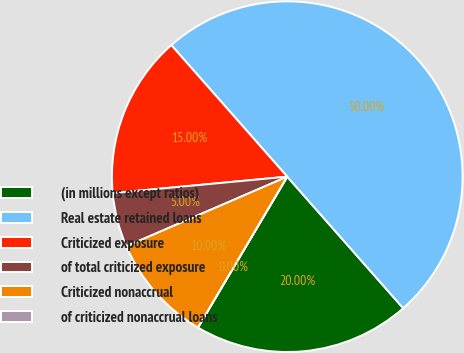Convert chart. <chart><loc_0><loc_0><loc_500><loc_500><pie_chart><fcel>(in millions except ratios)<fcel>Real estate retained loans<fcel>Criticized exposure<fcel>of total criticized exposure<fcel>Criticized nonaccrual<fcel>of criticized nonaccrual loans<nl><fcel>20.0%<fcel>50.0%<fcel>15.0%<fcel>5.0%<fcel>10.0%<fcel>0.0%<nl></chart> 